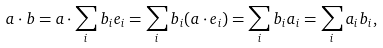<formula> <loc_0><loc_0><loc_500><loc_500>a \cdot b = a \cdot \sum _ { i } b _ { i } e _ { i } = \sum _ { i } b _ { i } ( a \cdot e _ { i } ) = \sum _ { i } b _ { i } a _ { i } = \sum _ { i } a _ { i } b _ { i } ,</formula> 